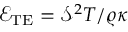Convert formula to latex. <formula><loc_0><loc_0><loc_500><loc_500>\mathcal { E } _ { T E } = { { { \mathcal { S } } ^ { 2 } T } / { \varrho \kappa } }</formula> 